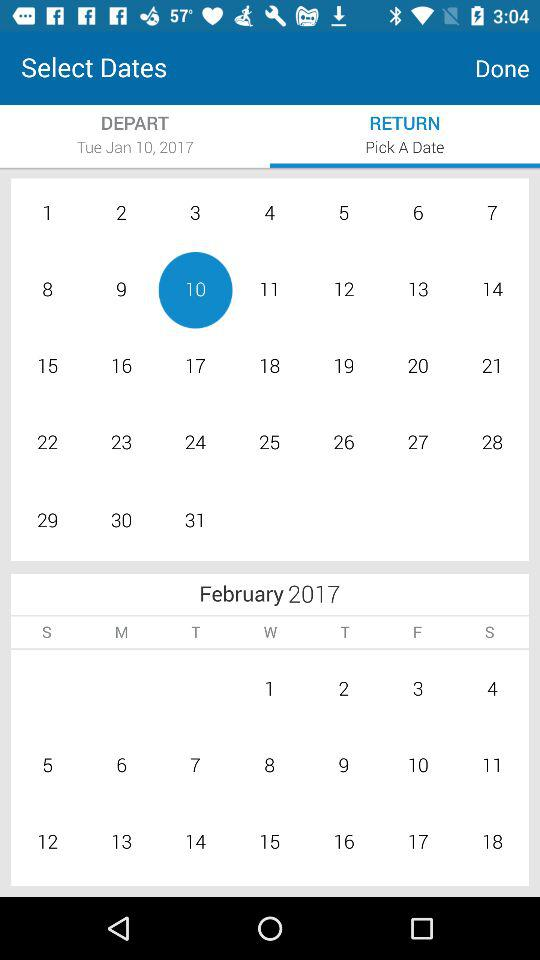Which option has been selected? The option that has been selected is "RETURN". 